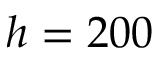Convert formula to latex. <formula><loc_0><loc_0><loc_500><loc_500>h = 2 0 0</formula> 